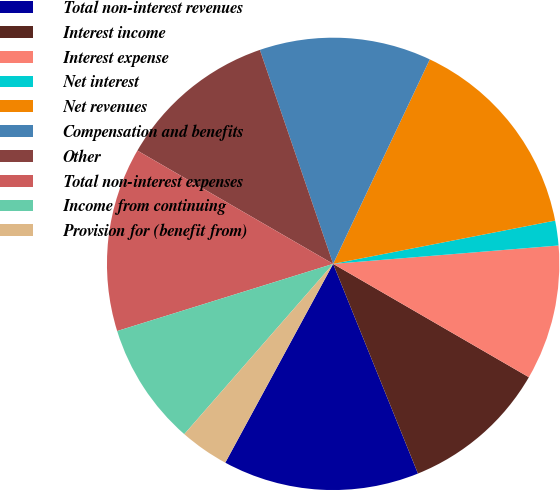Convert chart to OTSL. <chart><loc_0><loc_0><loc_500><loc_500><pie_chart><fcel>Total non-interest revenues<fcel>Interest income<fcel>Interest expense<fcel>Net interest<fcel>Net revenues<fcel>Compensation and benefits<fcel>Other<fcel>Total non-interest expenses<fcel>Income from continuing<fcel>Provision for (benefit from)<nl><fcel>14.03%<fcel>10.53%<fcel>9.65%<fcel>1.77%<fcel>14.91%<fcel>12.28%<fcel>11.4%<fcel>13.15%<fcel>8.77%<fcel>3.52%<nl></chart> 